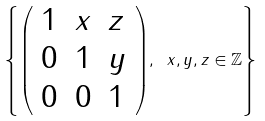Convert formula to latex. <formula><loc_0><loc_0><loc_500><loc_500>\left \{ { \left ( \begin{array} { l l l } { 1 } & { x } & { z } \\ { 0 } & { 1 } & { y } \\ { 0 } & { 0 } & { 1 } \end{array} \right ) } , \ x , y , z \in \mathbb { Z } \right \}</formula> 